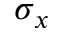<formula> <loc_0><loc_0><loc_500><loc_500>\sigma _ { x }</formula> 